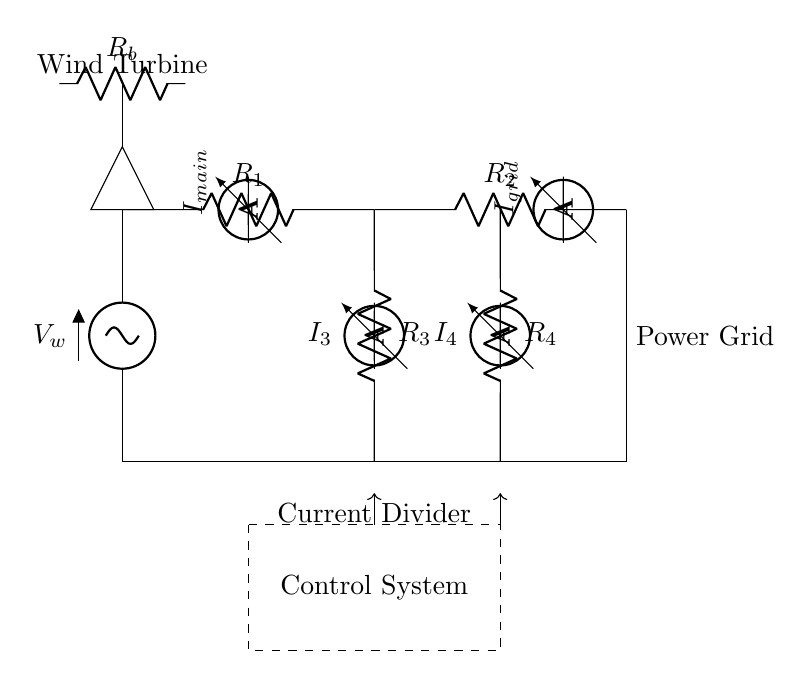What is the total resistance in the main path? The total resistance can be found by adding the resistances in series. In the main path, there are resistors R1 and R2, so the total resistance is R1 + R2.
Answer: R1 + R2 What is the purpose of the current divider in this circuit? The current divider splits the main current into branches, allowing different currents to flow through each resistor in the current divider. It regulates power output and grid integration.
Answer: Regulating power output What is the current flowing through resistor R3? To find the current through R3, we apply the current divider rule, which states that the current splits inversely proportional to the resistances in parallel. The current through R3 is I_main multiplied by R4 / (R3 + R4).
Answer: I_main * R4 / (R3 + R4) What does the dashed rectangle represent in the circuit? The dashed rectangle represents the control system, which is an additional component designed to manage and optimize the performance of the wind turbine in relation to power output and grid stability.
Answer: Control system How many ammeters are included in the setup? The circuit diagram displays four ammeters, each placed in different branches to measure current flow in the main circuit and the current divider branches.
Answer: Four What happens to the current when the resistance of R4 increases? If the resistance of R4 increases, according to the current divider rule, the current through R4 will decrease while the current through R3 will increase, affecting how the total current is shared between the two branches.
Answer: Current through R4 decreases 